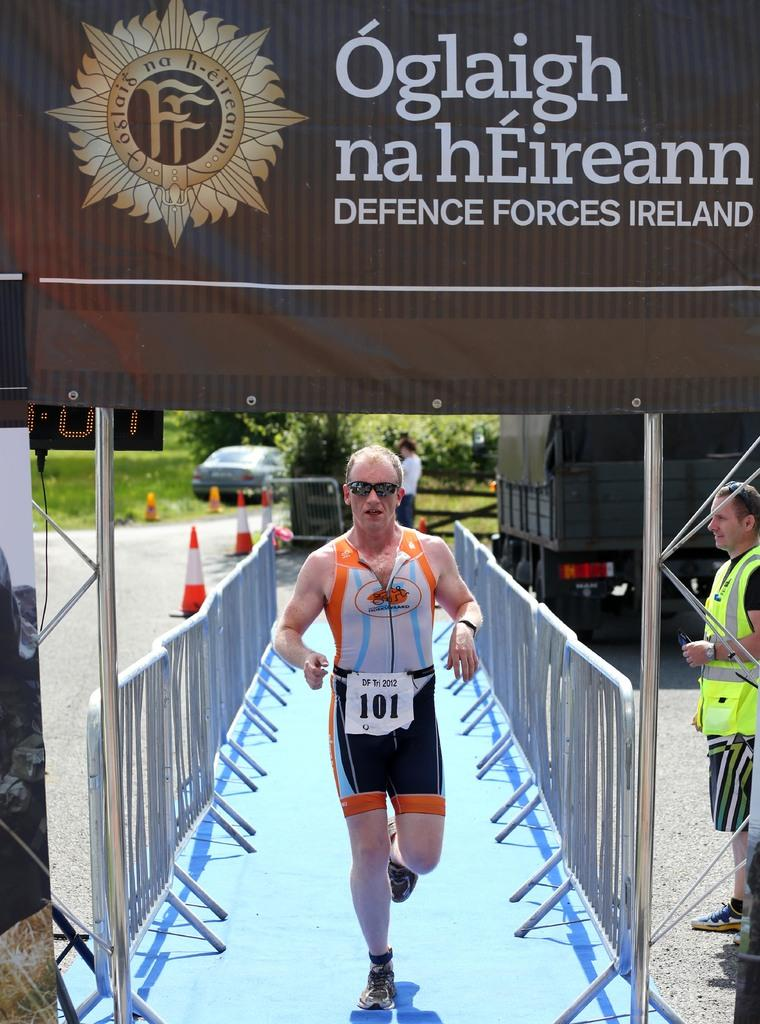<image>
Relay a brief, clear account of the picture shown. a man running outside with 101 on him' 